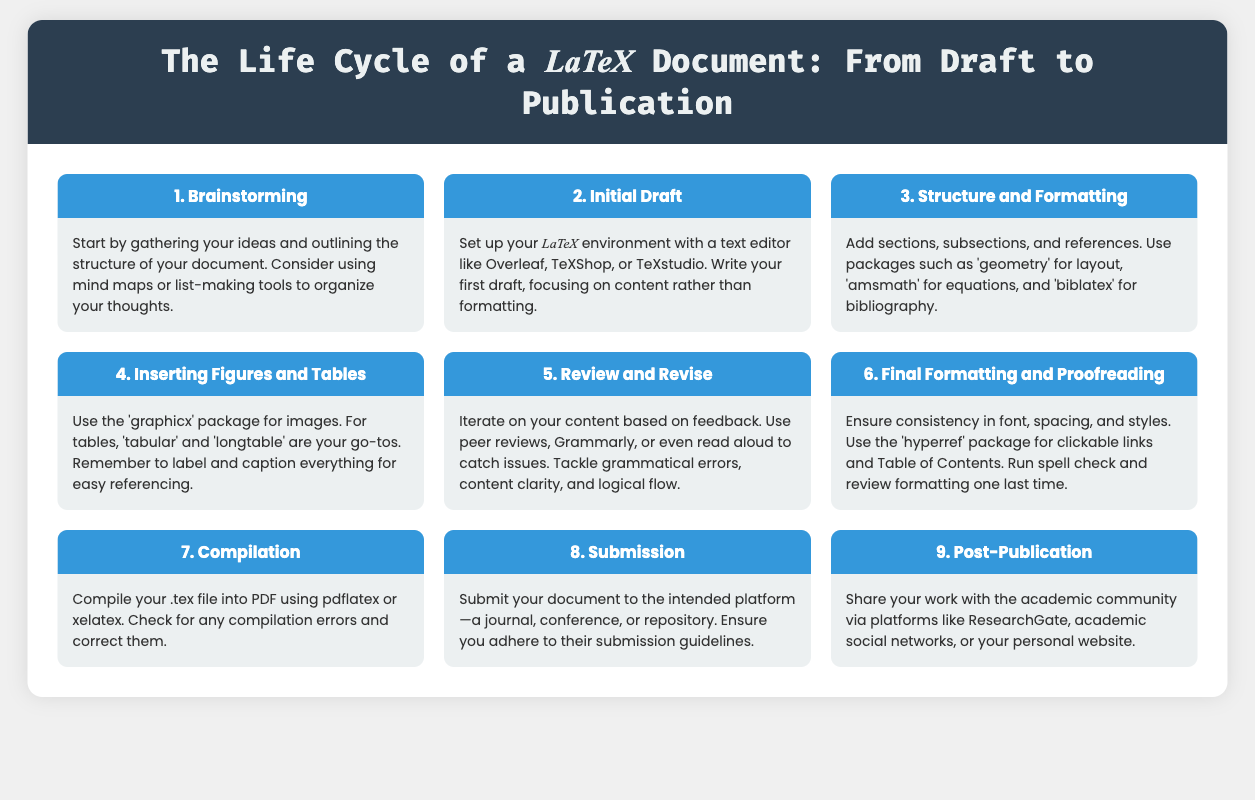what is the first step in the life cycle? The first step in the life cycle is to brainstorm ideas and outline the structure of your document.
Answer: Brainstorming what package is used for bibliography management? The 'biblatex' package is mentioned for bibliography management in the document.
Answer: biblatex how many main sections are outlined in the infographic? There are nine main sections outlined in the infographic covering the life cycle.
Answer: 9 which LaTeX package is recommended for inserting figures? The document suggests using the 'graphicx' package for inserting figures.
Answer: graphicx what is the final step before submission? The final step before submission is to compile the document into a PDF format.
Answer: Compilation what should be ensured during final formatting? Consistency in font, spacing, and styles should be ensured during final formatting.
Answer: Consistency in font, spacing, and styles which tools can be used for content review? Peer reviews, Grammarly, or reading aloud are recommended for content review.
Answer: Peer reviews, Grammarly, or reading aloud what is emphasized after document publication? Sharing your work with the academic community is emphasized after publication.
Answer: Share your work what type of tools are suggested for outlining ideas? Mind maps or list-making tools are suggested for outlining ideas during brainstorming.
Answer: Mind maps or list-making tools 